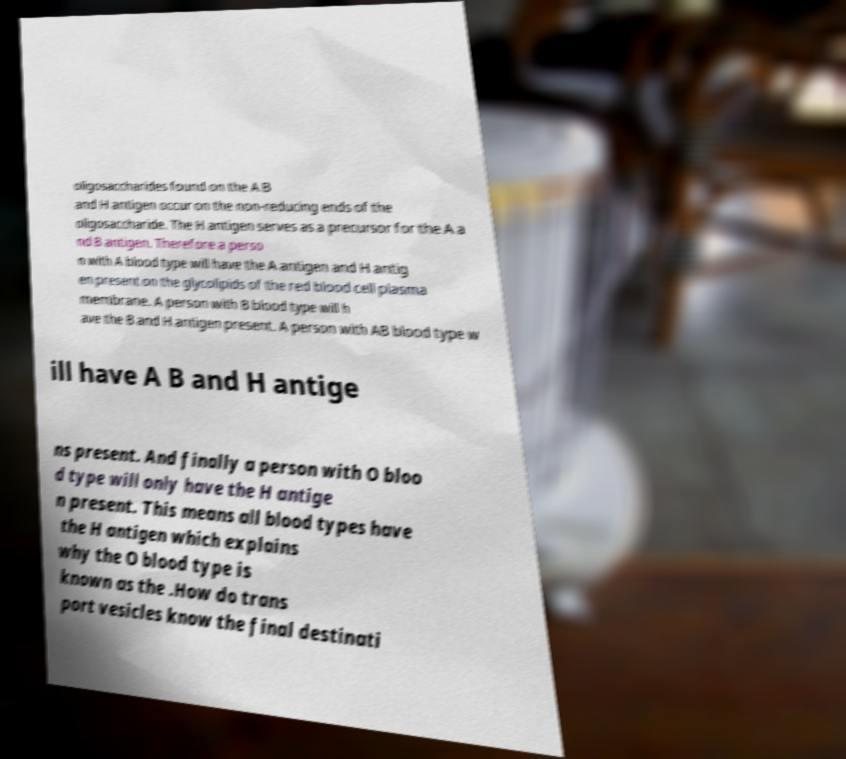I need the written content from this picture converted into text. Can you do that? oligosaccharides found on the A B and H antigen occur on the non-reducing ends of the oligosaccharide. The H antigen serves as a precursor for the A a nd B antigen. Therefore a perso n with A blood type will have the A antigen and H antig en present on the glycolipids of the red blood cell plasma membrane. A person with B blood type will h ave the B and H antigen present. A person with AB blood type w ill have A B and H antige ns present. And finally a person with O bloo d type will only have the H antige n present. This means all blood types have the H antigen which explains why the O blood type is known as the .How do trans port vesicles know the final destinati 